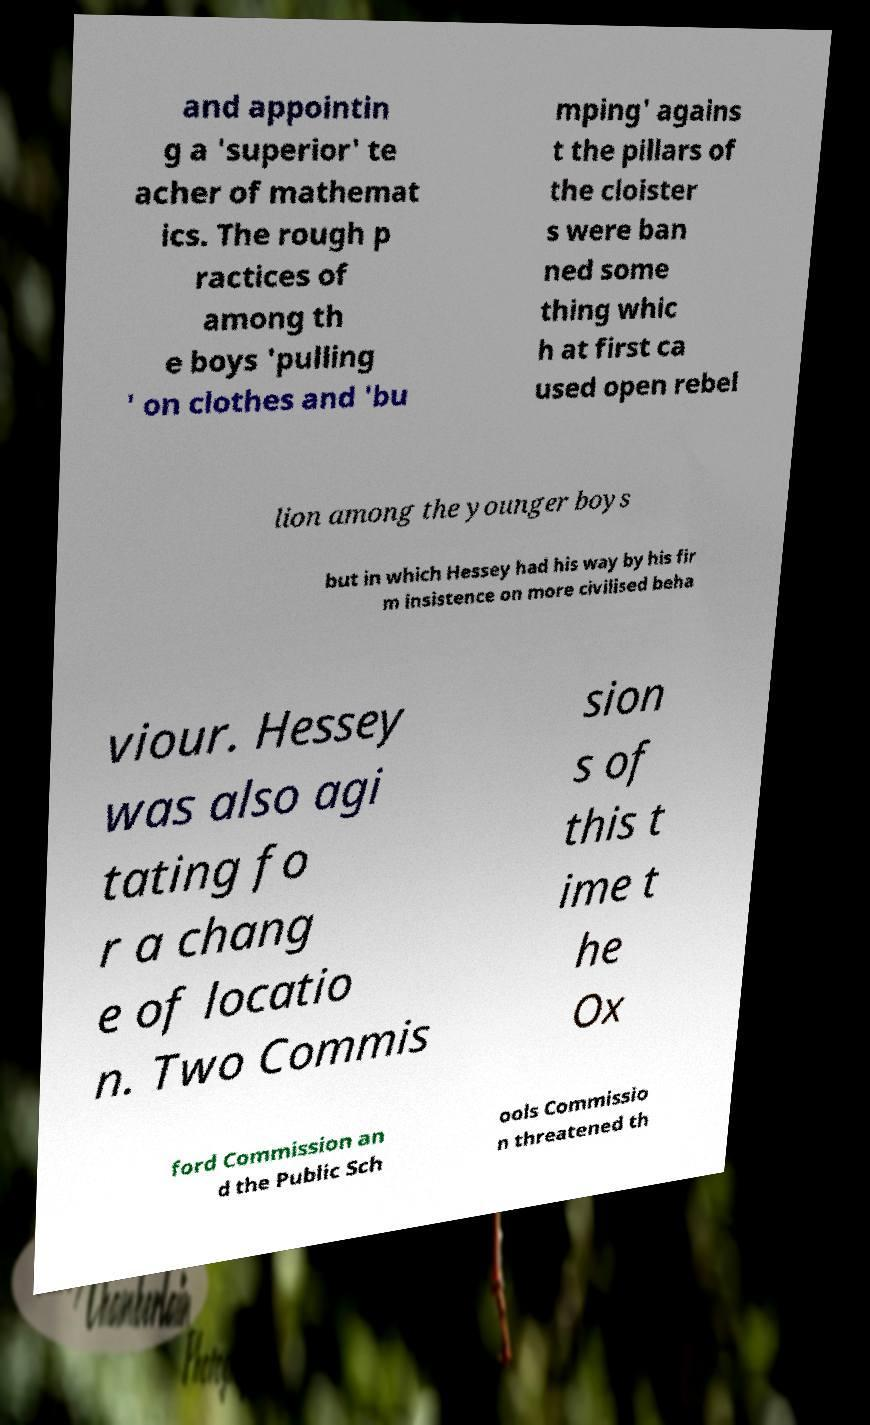Could you assist in decoding the text presented in this image and type it out clearly? and appointin g a 'superior' te acher of mathemat ics. The rough p ractices of among th e boys 'pulling ' on clothes and 'bu mping' agains t the pillars of the cloister s were ban ned some thing whic h at first ca used open rebel lion among the younger boys but in which Hessey had his way by his fir m insistence on more civilised beha viour. Hessey was also agi tating fo r a chang e of locatio n. Two Commis sion s of this t ime t he Ox ford Commission an d the Public Sch ools Commissio n threatened th 